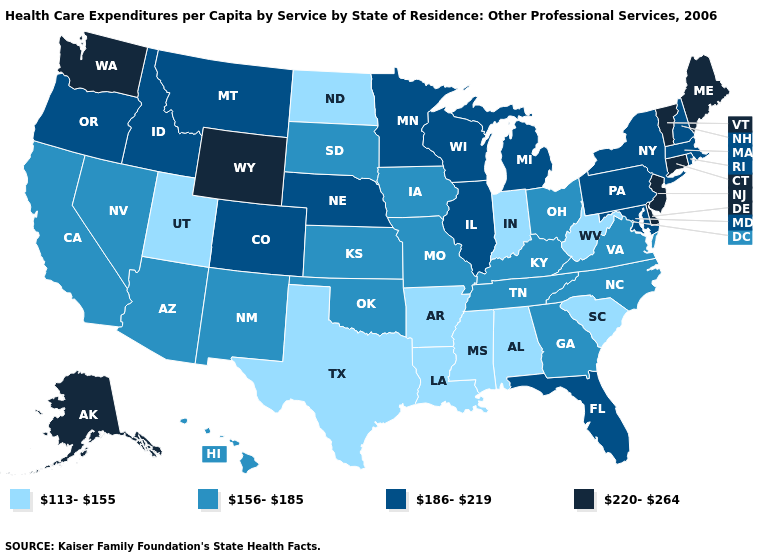Name the states that have a value in the range 156-185?
Be succinct. Arizona, California, Georgia, Hawaii, Iowa, Kansas, Kentucky, Missouri, Nevada, New Mexico, North Carolina, Ohio, Oklahoma, South Dakota, Tennessee, Virginia. Does New Hampshire have the lowest value in the Northeast?
Keep it brief. Yes. Name the states that have a value in the range 156-185?
Quick response, please. Arizona, California, Georgia, Hawaii, Iowa, Kansas, Kentucky, Missouri, Nevada, New Mexico, North Carolina, Ohio, Oklahoma, South Dakota, Tennessee, Virginia. How many symbols are there in the legend?
Quick response, please. 4. Does North Dakota have the lowest value in the MidWest?
Give a very brief answer. Yes. Does the first symbol in the legend represent the smallest category?
Give a very brief answer. Yes. Name the states that have a value in the range 220-264?
Quick response, please. Alaska, Connecticut, Delaware, Maine, New Jersey, Vermont, Washington, Wyoming. What is the lowest value in states that border Georgia?
Answer briefly. 113-155. Does Arkansas have a higher value than Nebraska?
Give a very brief answer. No. What is the lowest value in the USA?
Be succinct. 113-155. Name the states that have a value in the range 186-219?
Give a very brief answer. Colorado, Florida, Idaho, Illinois, Maryland, Massachusetts, Michigan, Minnesota, Montana, Nebraska, New Hampshire, New York, Oregon, Pennsylvania, Rhode Island, Wisconsin. What is the value of Colorado?
Answer briefly. 186-219. What is the value of Washington?
Quick response, please. 220-264. Which states have the highest value in the USA?
Short answer required. Alaska, Connecticut, Delaware, Maine, New Jersey, Vermont, Washington, Wyoming. Does Delaware have the highest value in the USA?
Answer briefly. Yes. 